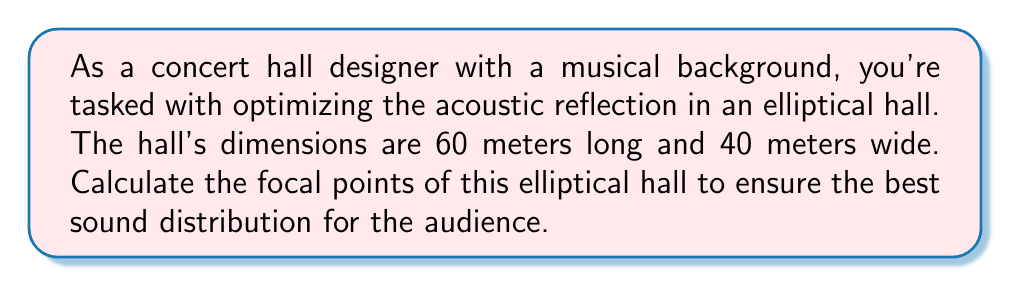What is the answer to this math problem? Let's approach this step-by-step:

1) An ellipse has two focal points. The equation of an ellipse with center at the origin is:

   $$\frac{x^2}{a^2} + \frac{y^2}{b^2} = 1$$

   where $a$ is the semi-major axis and $b$ is the semi-minor axis.

2) In this case:
   - Length = 60 m, so $a = 30$ m (half of the length)
   - Width = 40 m, so $b = 20$ m (half of the width)

3) The distance $c$ from the center to each focal point is given by the formula:

   $$c^2 = a^2 - b^2$$

4) Let's calculate $c$:
   
   $$c^2 = 30^2 - 20^2 = 900 - 400 = 500$$
   $$c = \sqrt{500} = 10\sqrt{5} \approx 22.36$$

5) The focal points are located at $(±c, 0)$ on the x-axis. So, they are at:

   $$(10\sqrt{5}, 0)$$ and $$(-10\sqrt{5}, 0)$$

6) To express this in meters from the center of the hall:
   The focal points are approximately 22.36 meters to the left and right of the center.

[asy]
import geometry;

size(200);
ellipse e = ellipse((0,0), 30, 20);
draw(e);
dot((22.36,0), red);
dot((-22.36,0), red);
draw((0,0)--(22.36,0), dashed);
draw((0,0)--(-22.36,0), dashed);
label("F1", (22.36,0), E);
label("F2", (-22.36,0), W);
label("Center", (0,0), S);
[/asy]
Answer: $(±10\sqrt{5}, 0)$ meters from center 